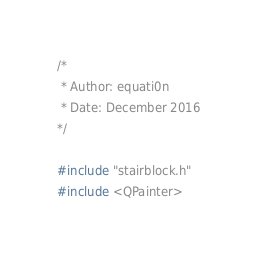Convert code to text. <code><loc_0><loc_0><loc_500><loc_500><_C++_>/*
 * Author: equati0n
 * Date: December 2016
*/

#include "stairblock.h"
#include <QPainter>
</code> 